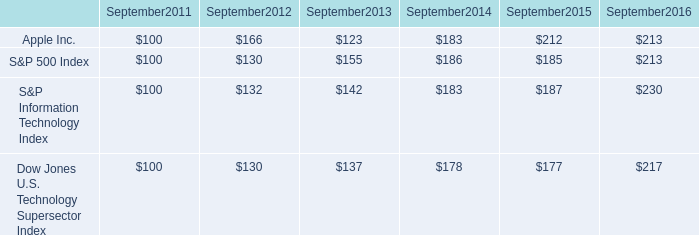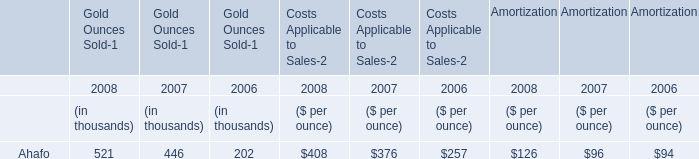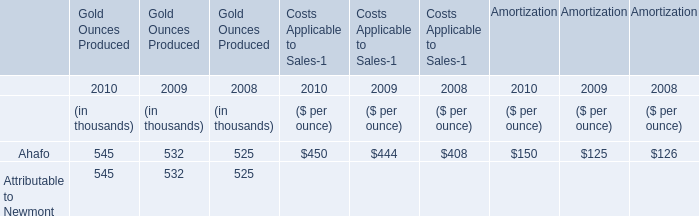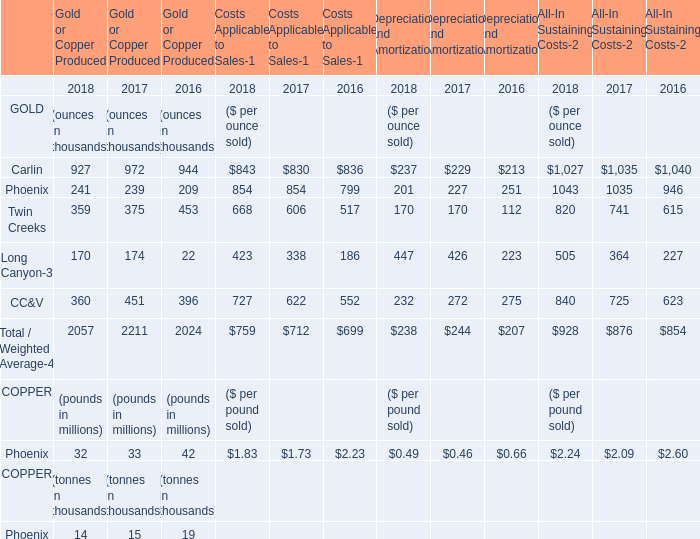What is the sum of Attributable to Newmont of Gold Ounces Produced in 2008 and Ahafo of Gold Ounces Sold in 2006? (in thousand) 
Computations: (525 + 202)
Answer: 727.0. 